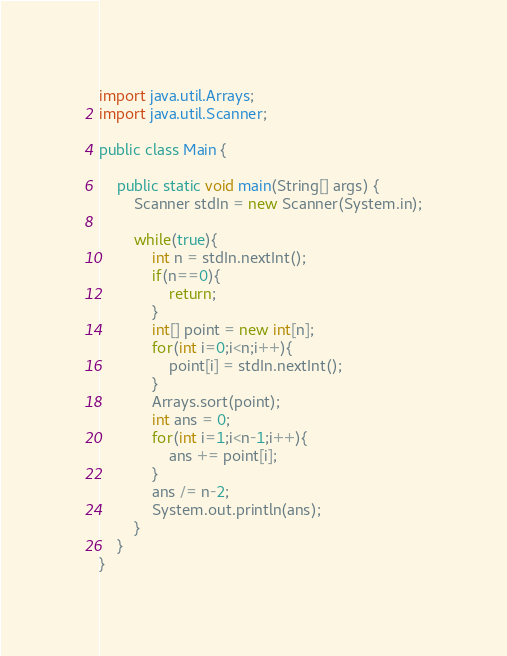<code> <loc_0><loc_0><loc_500><loc_500><_Java_>import java.util.Arrays;
import java.util.Scanner;

public class Main {

	public static void main(String[] args) {
		Scanner stdIn = new Scanner(System.in);
		
		while(true){
			int n = stdIn.nextInt();
			if(n==0){
				return;
			}
			int[] point = new int[n];
			for(int i=0;i<n;i++){
				point[i] = stdIn.nextInt();
			}
			Arrays.sort(point);
			int ans = 0;
			for(int i=1;i<n-1;i++){
				ans += point[i];
			}
			ans /= n-2;
			System.out.println(ans);
		}
	}
}</code> 